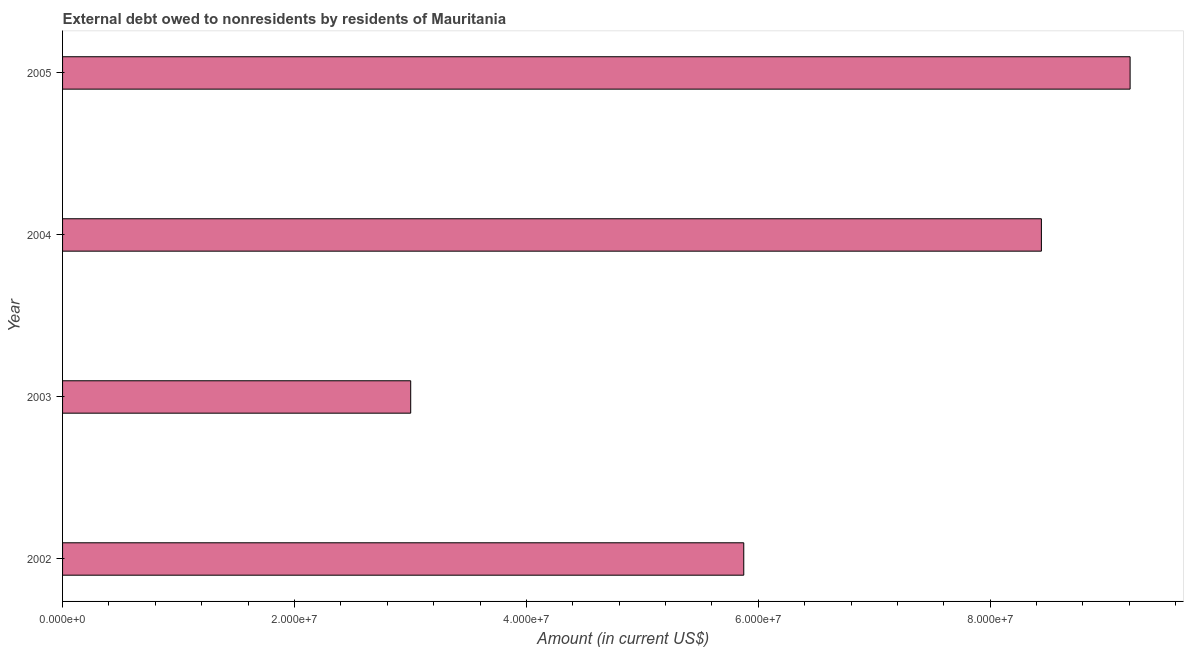Does the graph contain any zero values?
Offer a very short reply. No. Does the graph contain grids?
Offer a terse response. No. What is the title of the graph?
Keep it short and to the point. External debt owed to nonresidents by residents of Mauritania. What is the debt in 2003?
Provide a succinct answer. 3.00e+07. Across all years, what is the maximum debt?
Make the answer very short. 9.21e+07. Across all years, what is the minimum debt?
Provide a succinct answer. 3.00e+07. In which year was the debt maximum?
Your answer should be very brief. 2005. What is the sum of the debt?
Keep it short and to the point. 2.65e+08. What is the difference between the debt in 2002 and 2004?
Make the answer very short. -2.57e+07. What is the average debt per year?
Provide a succinct answer. 6.63e+07. What is the median debt?
Offer a very short reply. 7.16e+07. Do a majority of the years between 2003 and 2005 (inclusive) have debt greater than 72000000 US$?
Make the answer very short. Yes. What is the ratio of the debt in 2003 to that in 2004?
Offer a very short reply. 0.36. Is the difference between the debt in 2002 and 2003 greater than the difference between any two years?
Offer a terse response. No. What is the difference between the highest and the second highest debt?
Provide a succinct answer. 7.65e+06. What is the difference between the highest and the lowest debt?
Make the answer very short. 6.20e+07. In how many years, is the debt greater than the average debt taken over all years?
Your answer should be very brief. 2. Are all the bars in the graph horizontal?
Provide a succinct answer. Yes. How many years are there in the graph?
Keep it short and to the point. 4. What is the difference between two consecutive major ticks on the X-axis?
Keep it short and to the point. 2.00e+07. What is the Amount (in current US$) in 2002?
Keep it short and to the point. 5.87e+07. What is the Amount (in current US$) of 2003?
Your answer should be compact. 3.00e+07. What is the Amount (in current US$) of 2004?
Ensure brevity in your answer.  8.44e+07. What is the Amount (in current US$) of 2005?
Provide a short and direct response. 9.21e+07. What is the difference between the Amount (in current US$) in 2002 and 2003?
Keep it short and to the point. 2.87e+07. What is the difference between the Amount (in current US$) in 2002 and 2004?
Offer a very short reply. -2.57e+07. What is the difference between the Amount (in current US$) in 2002 and 2005?
Offer a terse response. -3.33e+07. What is the difference between the Amount (in current US$) in 2003 and 2004?
Your response must be concise. -5.44e+07. What is the difference between the Amount (in current US$) in 2003 and 2005?
Offer a very short reply. -6.20e+07. What is the difference between the Amount (in current US$) in 2004 and 2005?
Offer a terse response. -7.65e+06. What is the ratio of the Amount (in current US$) in 2002 to that in 2003?
Offer a terse response. 1.96. What is the ratio of the Amount (in current US$) in 2002 to that in 2004?
Offer a terse response. 0.7. What is the ratio of the Amount (in current US$) in 2002 to that in 2005?
Your answer should be very brief. 0.64. What is the ratio of the Amount (in current US$) in 2003 to that in 2004?
Offer a terse response. 0.36. What is the ratio of the Amount (in current US$) in 2003 to that in 2005?
Ensure brevity in your answer.  0.33. What is the ratio of the Amount (in current US$) in 2004 to that in 2005?
Provide a succinct answer. 0.92. 